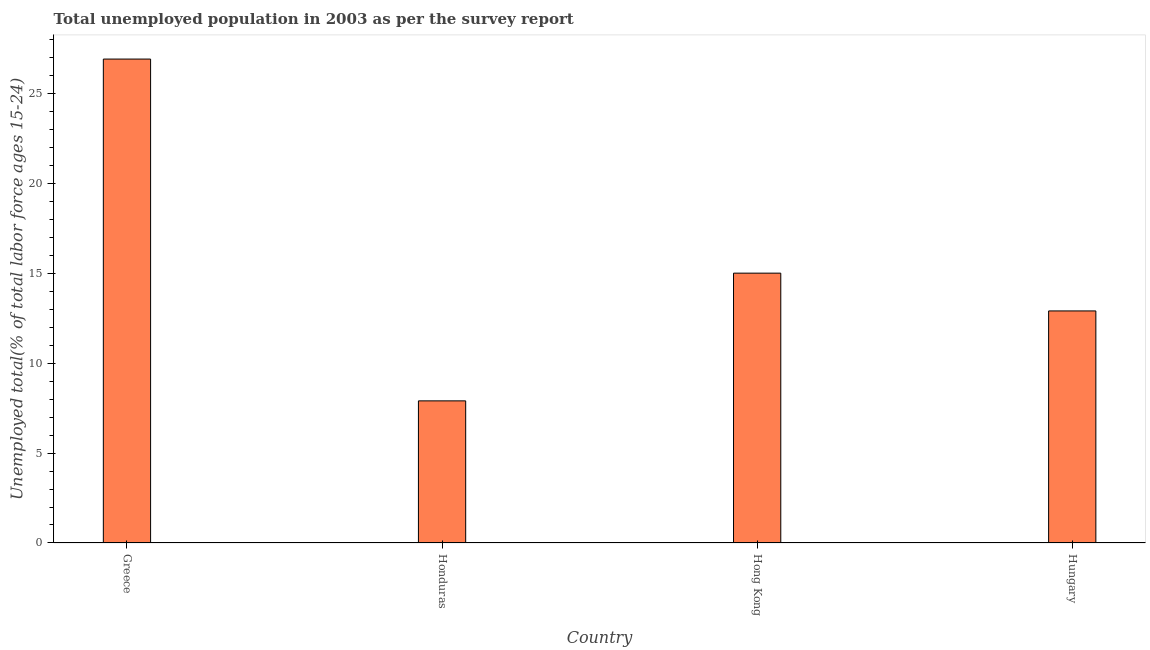Does the graph contain any zero values?
Give a very brief answer. No. Does the graph contain grids?
Make the answer very short. No. What is the title of the graph?
Your response must be concise. Total unemployed population in 2003 as per the survey report. What is the label or title of the X-axis?
Provide a succinct answer. Country. What is the label or title of the Y-axis?
Provide a short and direct response. Unemployed total(% of total labor force ages 15-24). What is the unemployed youth in Hong Kong?
Your answer should be compact. 15. Across all countries, what is the maximum unemployed youth?
Offer a very short reply. 26.9. Across all countries, what is the minimum unemployed youth?
Your response must be concise. 7.9. In which country was the unemployed youth maximum?
Your answer should be very brief. Greece. In which country was the unemployed youth minimum?
Provide a short and direct response. Honduras. What is the sum of the unemployed youth?
Make the answer very short. 62.7. What is the difference between the unemployed youth in Honduras and Hong Kong?
Offer a terse response. -7.1. What is the average unemployed youth per country?
Ensure brevity in your answer.  15.68. What is the median unemployed youth?
Keep it short and to the point. 13.95. What is the ratio of the unemployed youth in Greece to that in Honduras?
Give a very brief answer. 3.4. What is the difference between the highest and the lowest unemployed youth?
Ensure brevity in your answer.  19. In how many countries, is the unemployed youth greater than the average unemployed youth taken over all countries?
Your answer should be compact. 1. How many bars are there?
Keep it short and to the point. 4. How many countries are there in the graph?
Offer a very short reply. 4. What is the difference between two consecutive major ticks on the Y-axis?
Give a very brief answer. 5. What is the Unemployed total(% of total labor force ages 15-24) in Greece?
Your response must be concise. 26.9. What is the Unemployed total(% of total labor force ages 15-24) in Honduras?
Offer a very short reply. 7.9. What is the Unemployed total(% of total labor force ages 15-24) of Hungary?
Ensure brevity in your answer.  12.9. What is the difference between the Unemployed total(% of total labor force ages 15-24) in Greece and Hong Kong?
Give a very brief answer. 11.9. What is the difference between the Unemployed total(% of total labor force ages 15-24) in Greece and Hungary?
Ensure brevity in your answer.  14. What is the difference between the Unemployed total(% of total labor force ages 15-24) in Honduras and Hungary?
Your answer should be compact. -5. What is the difference between the Unemployed total(% of total labor force ages 15-24) in Hong Kong and Hungary?
Your answer should be very brief. 2.1. What is the ratio of the Unemployed total(% of total labor force ages 15-24) in Greece to that in Honduras?
Make the answer very short. 3.4. What is the ratio of the Unemployed total(% of total labor force ages 15-24) in Greece to that in Hong Kong?
Your answer should be very brief. 1.79. What is the ratio of the Unemployed total(% of total labor force ages 15-24) in Greece to that in Hungary?
Offer a terse response. 2.08. What is the ratio of the Unemployed total(% of total labor force ages 15-24) in Honduras to that in Hong Kong?
Give a very brief answer. 0.53. What is the ratio of the Unemployed total(% of total labor force ages 15-24) in Honduras to that in Hungary?
Your answer should be very brief. 0.61. What is the ratio of the Unemployed total(% of total labor force ages 15-24) in Hong Kong to that in Hungary?
Ensure brevity in your answer.  1.16. 